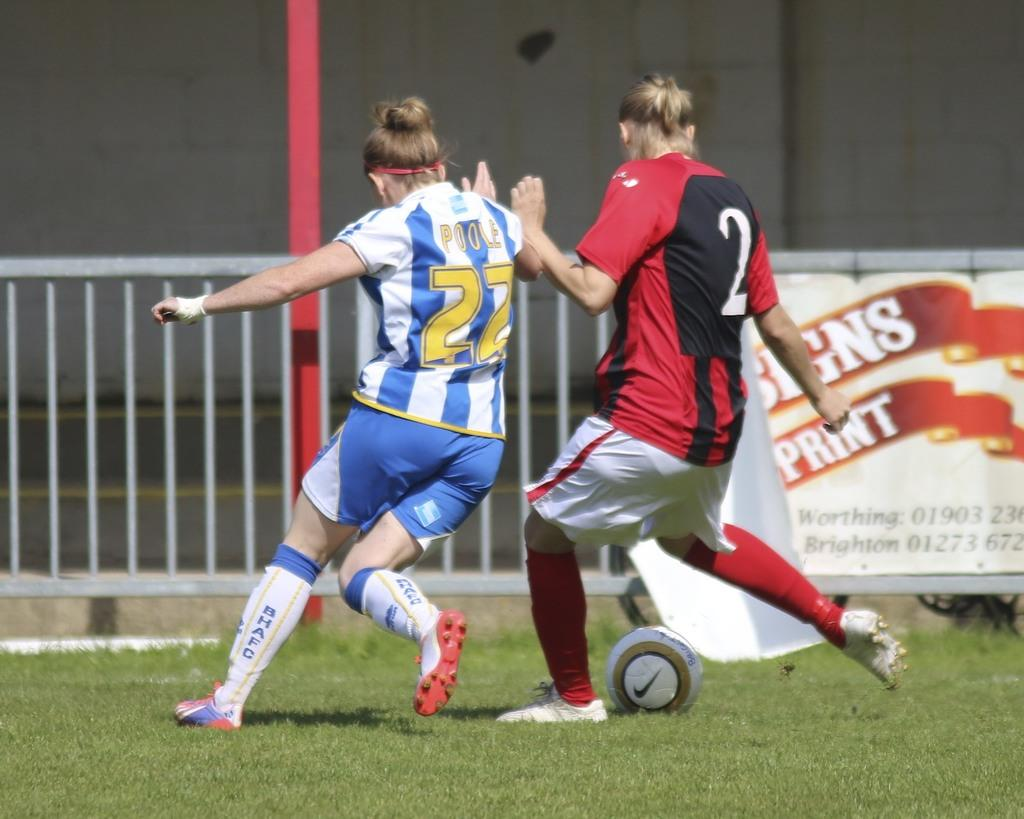How many people are in the image? There are two people in the image. What are the two people doing? The two people are playing a game. What action is one of the people taking in the game? One person is kicking a ball. What are the people wearing? Both people are wearing colorful shirts. What can be seen in the background of the image? There is a nice ground, a wall, and a banner in the background. How many geese are flying over the wall in the background? There are no geese visible in the image; only a wall and a banner can be seen in the background. What type of lumber is being used to construct the banner in the background? There is no lumber present in the image, as the banner is not being constructed; it is already hanging in the background. 